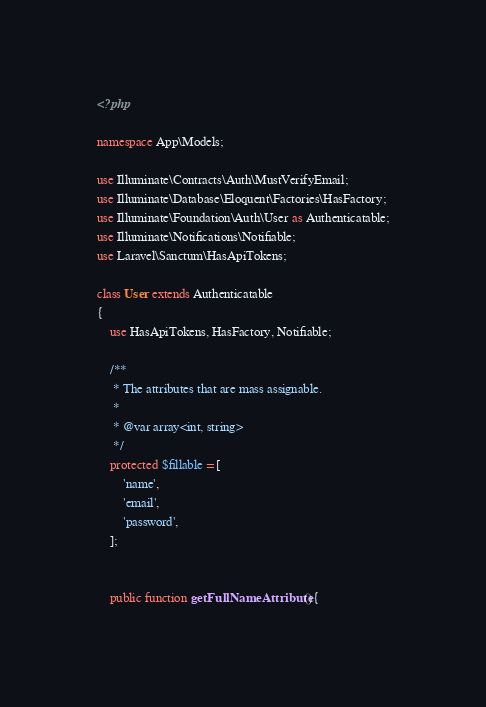Convert code to text. <code><loc_0><loc_0><loc_500><loc_500><_PHP_><?php

namespace App\Models;

use Illuminate\Contracts\Auth\MustVerifyEmail;
use Illuminate\Database\Eloquent\Factories\HasFactory;
use Illuminate\Foundation\Auth\User as Authenticatable;
use Illuminate\Notifications\Notifiable;
use Laravel\Sanctum\HasApiTokens;

class User extends Authenticatable
{
    use HasApiTokens, HasFactory, Notifiable;

    /**
     * The attributes that are mass assignable.
     *
     * @var array<int, string>
     */
    protected $fillable = [
        'name',
        'email',
        'password',
    ];


    public function getFullNameAttribute(){</code> 